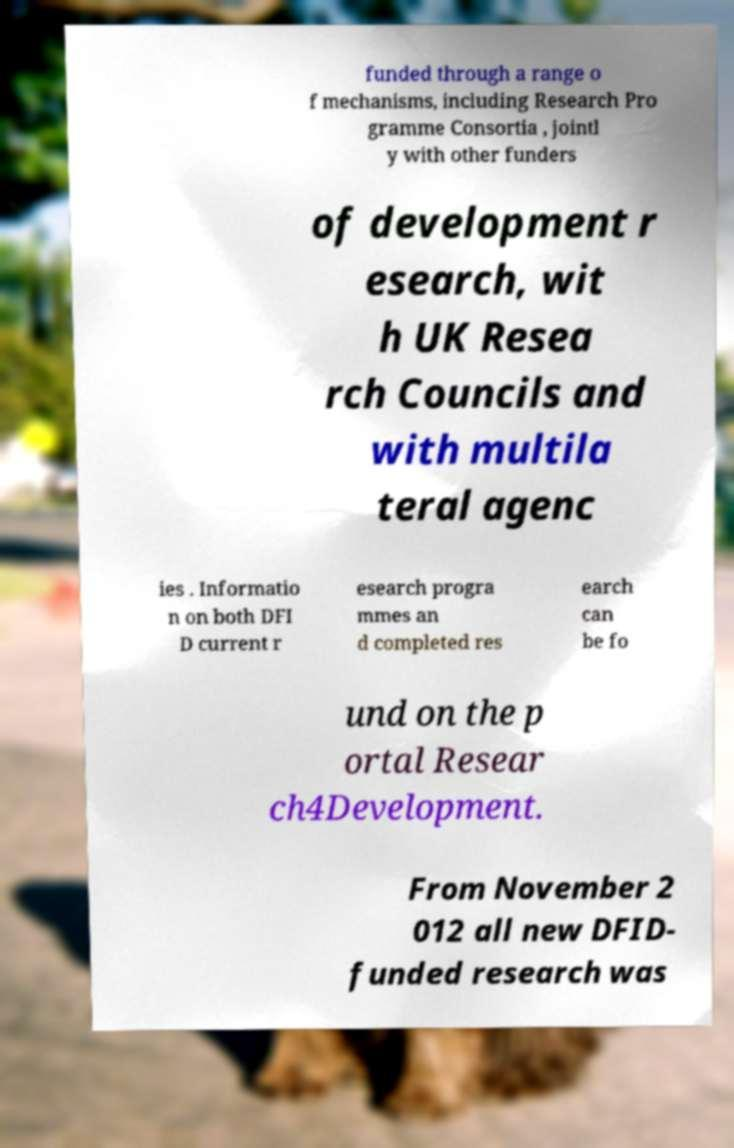There's text embedded in this image that I need extracted. Can you transcribe it verbatim? funded through a range o f mechanisms, including Research Pro gramme Consortia , jointl y with other funders of development r esearch, wit h UK Resea rch Councils and with multila teral agenc ies . Informatio n on both DFI D current r esearch progra mmes an d completed res earch can be fo und on the p ortal Resear ch4Development. From November 2 012 all new DFID- funded research was 